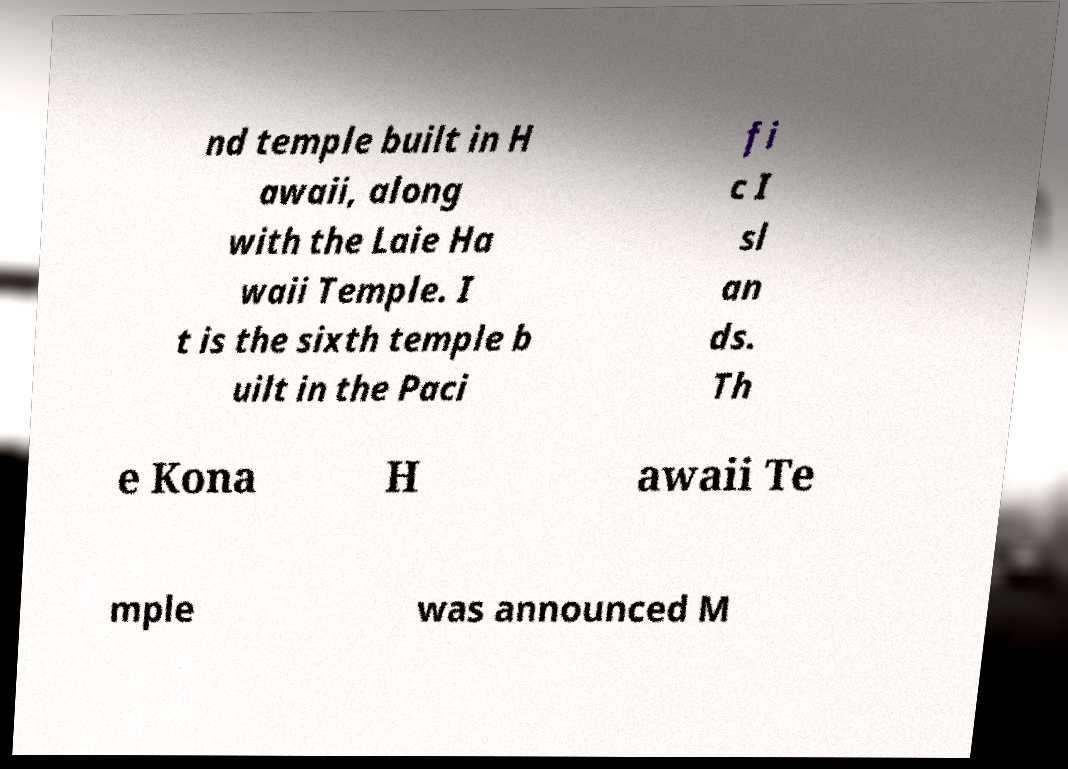Can you accurately transcribe the text from the provided image for me? nd temple built in H awaii, along with the Laie Ha waii Temple. I t is the sixth temple b uilt in the Paci fi c I sl an ds. Th e Kona H awaii Te mple was announced M 